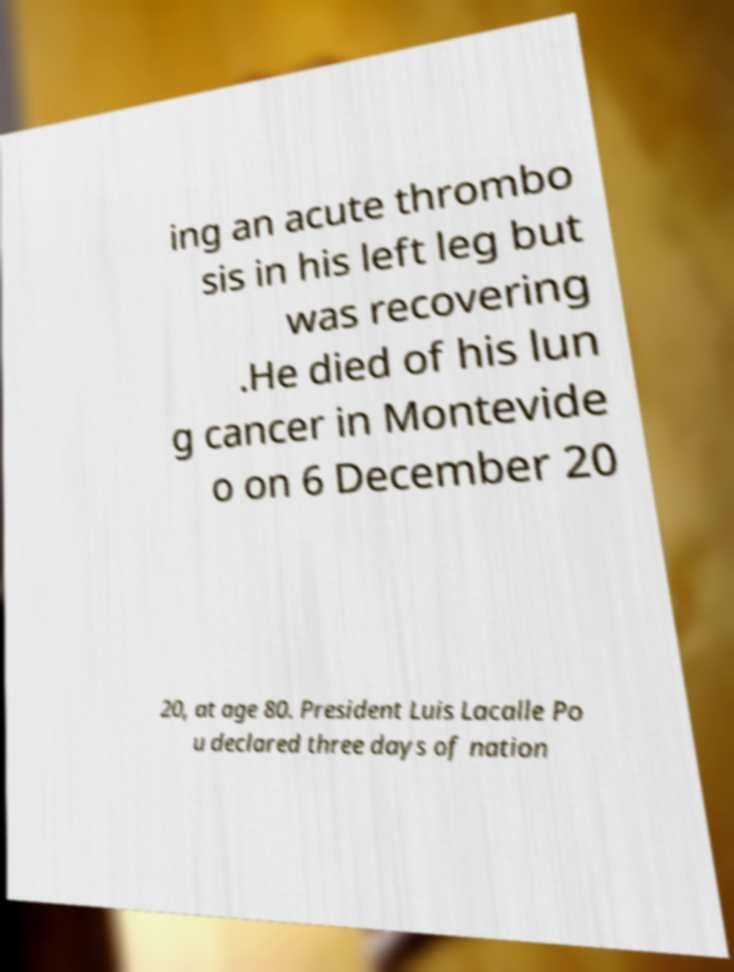I need the written content from this picture converted into text. Can you do that? ing an acute thrombo sis in his left leg but was recovering .He died of his lun g cancer in Montevide o on 6 December 20 20, at age 80. President Luis Lacalle Po u declared three days of nation 